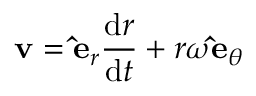<formula> <loc_0><loc_0><loc_500><loc_500>v = \hat { e } _ { r } { \frac { d r } { d t } } + r \omega \hat { e } _ { \theta }</formula> 